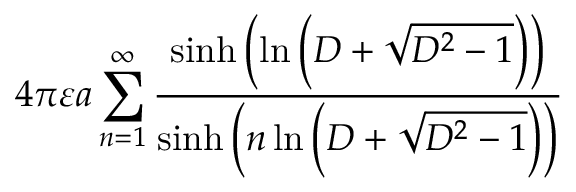<formula> <loc_0><loc_0><loc_500><loc_500>4 \pi \varepsilon a \sum _ { n = 1 } ^ { \infty } { \frac { \sinh \left ( \ln \left ( D + { \sqrt { D ^ { 2 } - 1 } } \right ) \right ) } { \sinh \left ( n \ln \left ( D + { \sqrt { D ^ { 2 } - 1 } } \right ) \right ) } }</formula> 